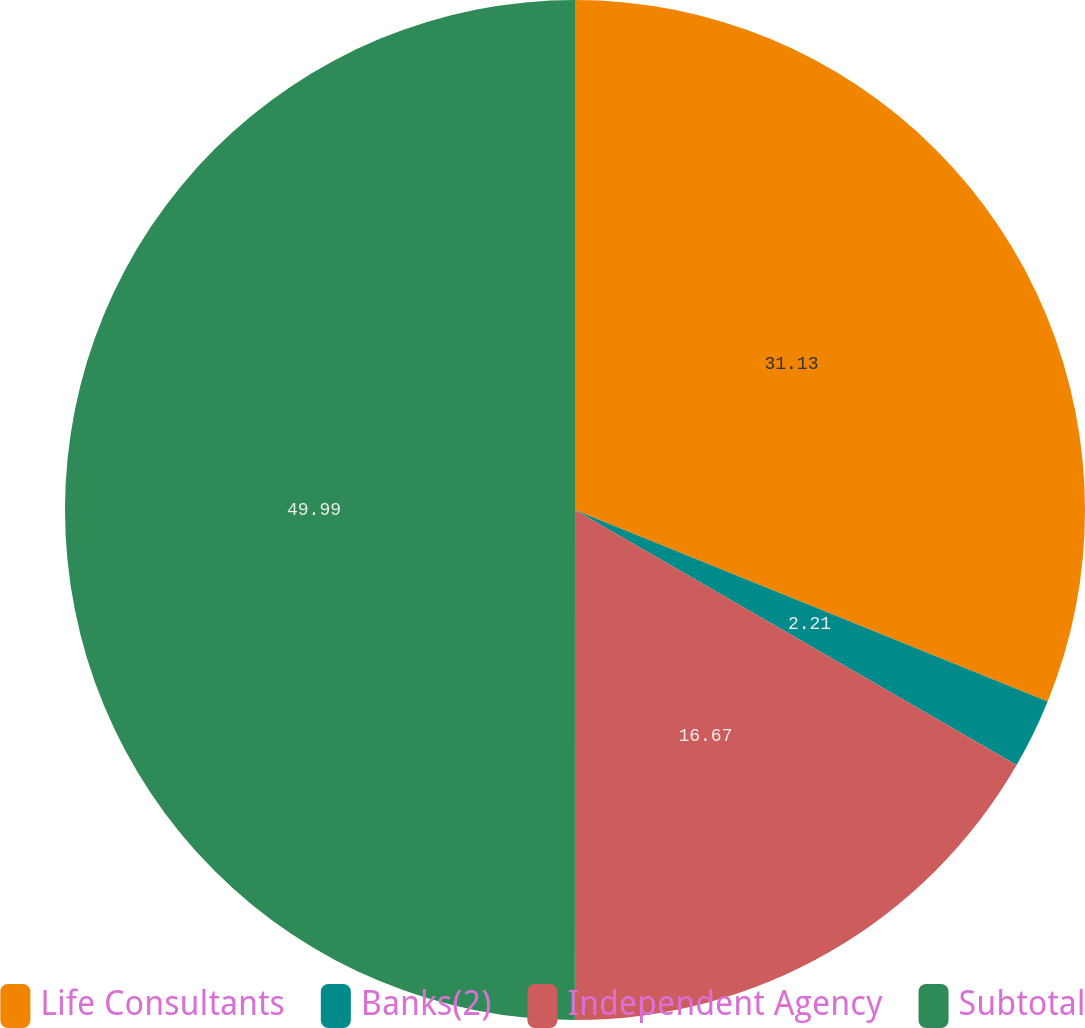Convert chart. <chart><loc_0><loc_0><loc_500><loc_500><pie_chart><fcel>Life Consultants<fcel>Banks(2)<fcel>Independent Agency<fcel>Subtotal<nl><fcel>31.13%<fcel>2.21%<fcel>16.67%<fcel>50.0%<nl></chart> 